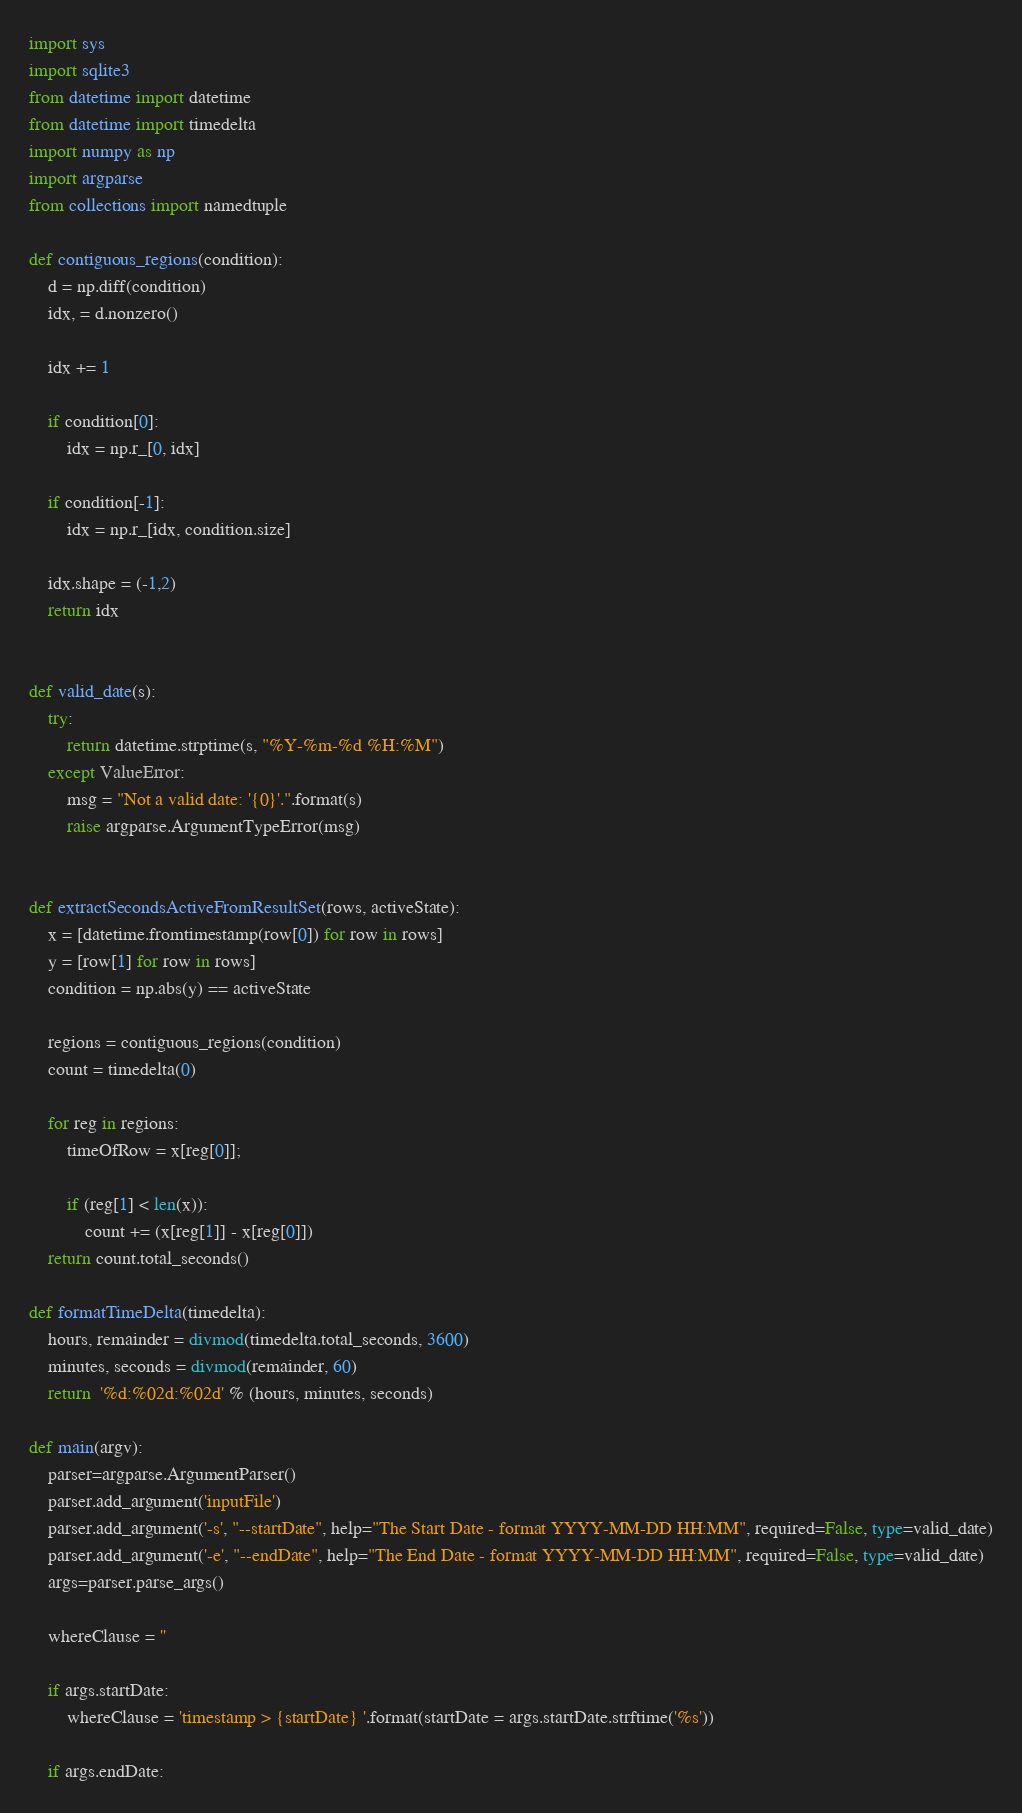<code> <loc_0><loc_0><loc_500><loc_500><_Python_>import sys
import sqlite3
from datetime import datetime
from datetime import timedelta
import numpy as np
import argparse
from collections import namedtuple

def contiguous_regions(condition):
    d = np.diff(condition)
    idx, = d.nonzero() 

    idx += 1

    if condition[0]:
        idx = np.r_[0, idx]

    if condition[-1]:
        idx = np.r_[idx, condition.size]

    idx.shape = (-1,2)
    return idx


def valid_date(s):
    try:
        return datetime.strptime(s, "%Y-%m-%d %H:%M")
    except ValueError:
        msg = "Not a valid date: '{0}'.".format(s)
        raise argparse.ArgumentTypeError(msg)


def extractSecondsActiveFromResultSet(rows, activeState):
	x = [datetime.fromtimestamp(row[0]) for row in rows]
	y = [row[1] for row in rows]
	condition = np.abs(y) == activeState

	regions = contiguous_regions(condition)
	count = timedelta(0)

	for reg in regions:
		timeOfRow = x[reg[0]];
	
		if (reg[1] < len(x)):
			count += (x[reg[1]] - x[reg[0]])
	return count.total_seconds()

def formatTimeDelta(timedelta):
	hours, remainder = divmod(timedelta.total_seconds, 3600)
	minutes, seconds = divmod(remainder, 60) 
	return  '%d:%02d:%02d' % (hours, minutes, seconds)

def main(argv):
	parser=argparse.ArgumentParser()
	parser.add_argument('inputFile')
	parser.add_argument('-s', "--startDate", help="The Start Date - format YYYY-MM-DD HH:MM", required=False, type=valid_date)
	parser.add_argument('-e', "--endDate", help="The End Date - format YYYY-MM-DD HH:MM", required=False, type=valid_date)
	args=parser.parse_args()

	whereClause = ''

	if args.startDate:
		whereClause = 'timestamp > {startDate} '.format(startDate = args.startDate.strftime('%s'))

	if args.endDate:</code> 